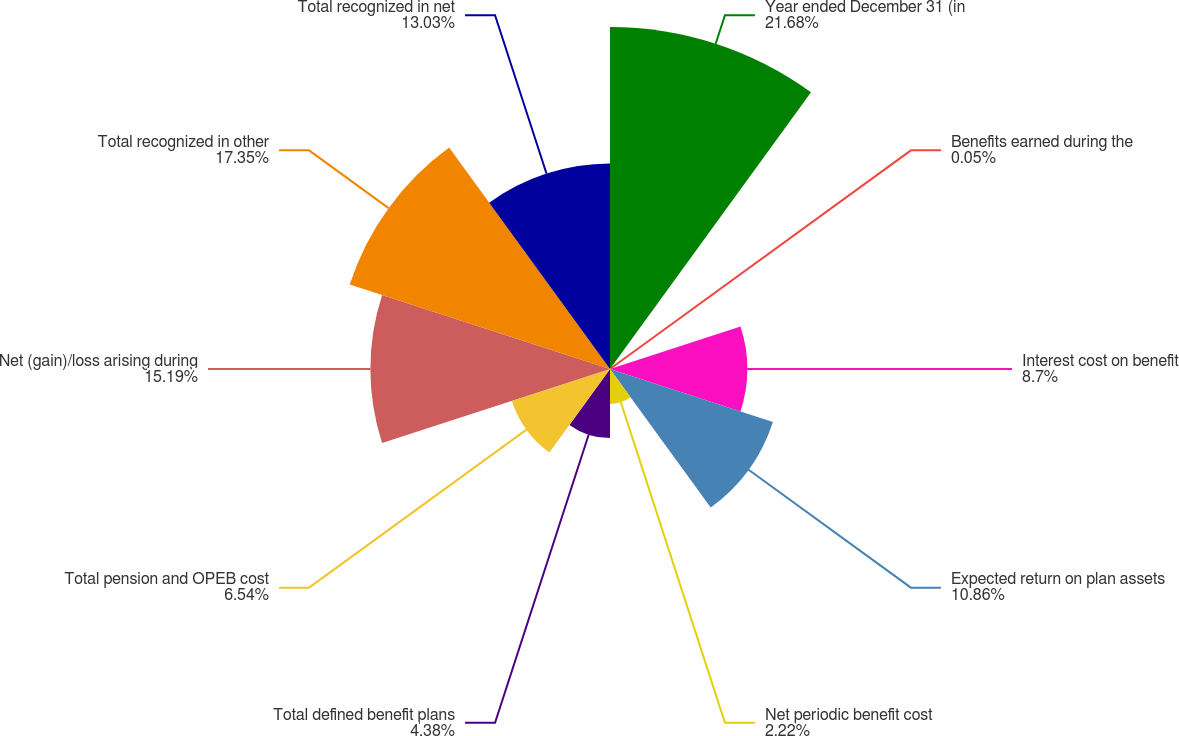<chart> <loc_0><loc_0><loc_500><loc_500><pie_chart><fcel>Year ended December 31 (in<fcel>Benefits earned during the<fcel>Interest cost on benefit<fcel>Expected return on plan assets<fcel>Net periodic benefit cost<fcel>Total defined benefit plans<fcel>Total pension and OPEB cost<fcel>Net (gain)/loss arising during<fcel>Total recognized in other<fcel>Total recognized in net<nl><fcel>21.68%<fcel>0.05%<fcel>8.7%<fcel>10.86%<fcel>2.22%<fcel>4.38%<fcel>6.54%<fcel>15.19%<fcel>17.35%<fcel>13.03%<nl></chart> 